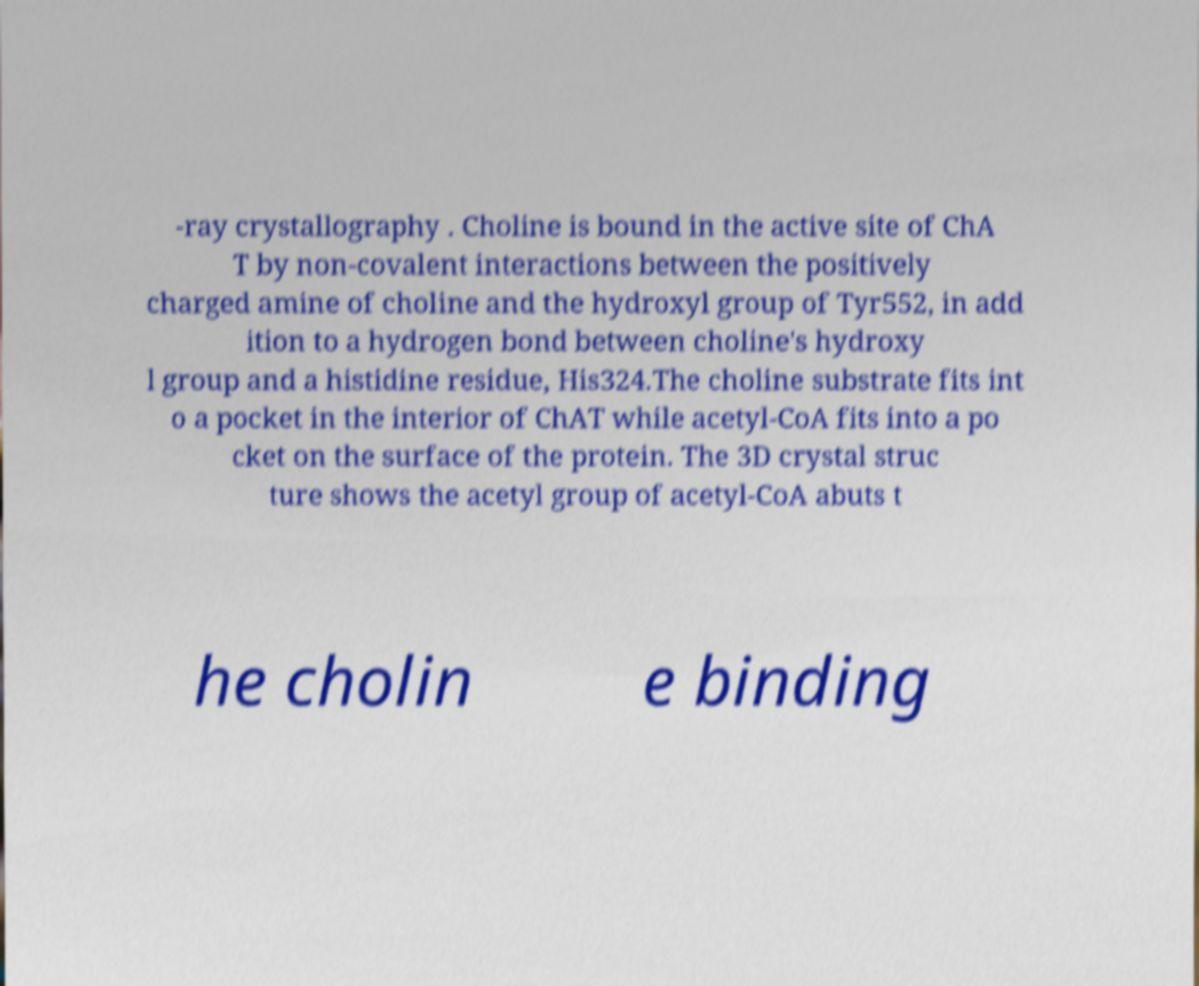Please read and relay the text visible in this image. What does it say? -ray crystallography . Choline is bound in the active site of ChA T by non-covalent interactions between the positively charged amine of choline and the hydroxyl group of Tyr552, in add ition to a hydrogen bond between choline's hydroxy l group and a histidine residue, His324.The choline substrate fits int o a pocket in the interior of ChAT while acetyl-CoA fits into a po cket on the surface of the protein. The 3D crystal struc ture shows the acetyl group of acetyl-CoA abuts t he cholin e binding 